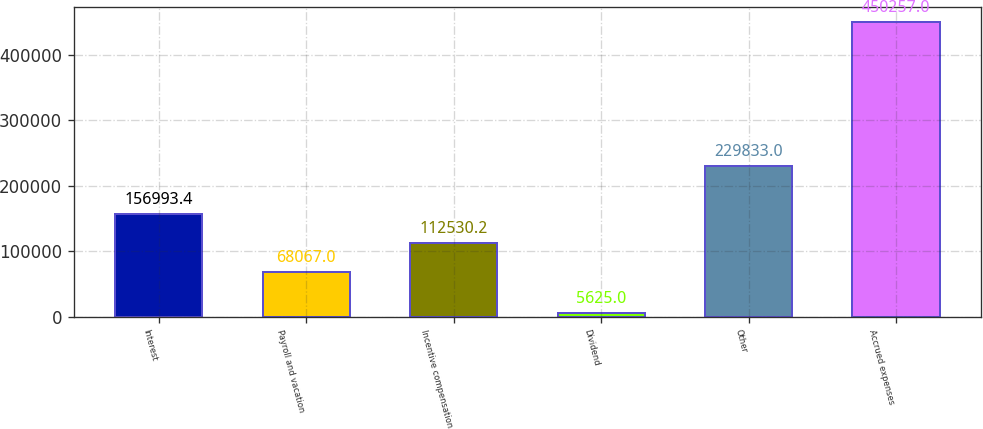Convert chart to OTSL. <chart><loc_0><loc_0><loc_500><loc_500><bar_chart><fcel>Interest<fcel>Payroll and vacation<fcel>Incentive compensation<fcel>Dividend<fcel>Other<fcel>Accrued expenses<nl><fcel>156993<fcel>68067<fcel>112530<fcel>5625<fcel>229833<fcel>450257<nl></chart> 